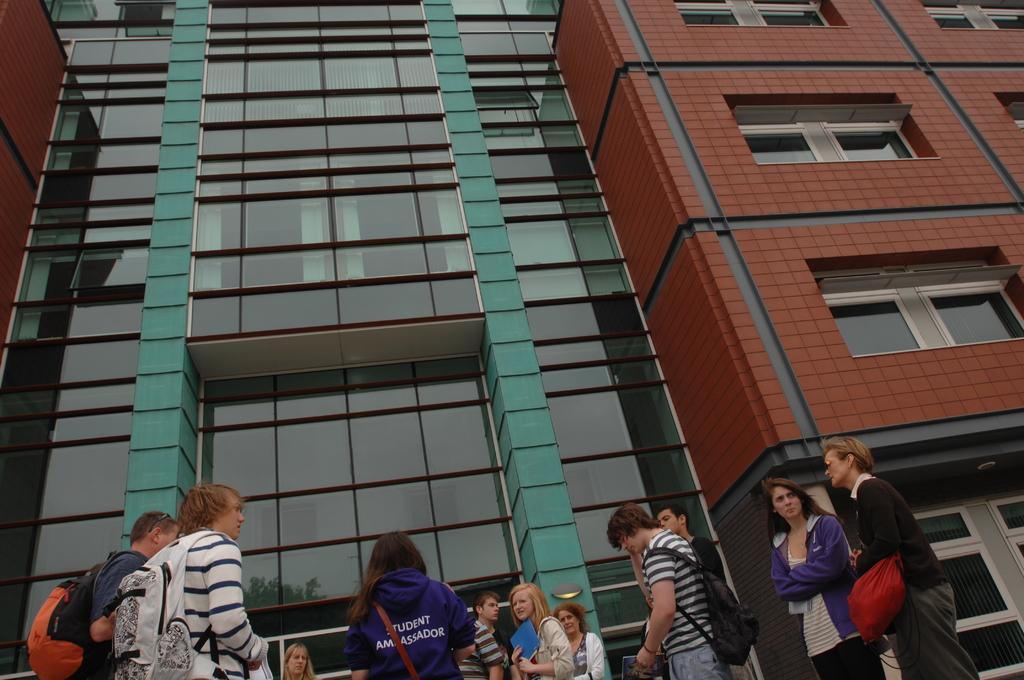How would you summarize this image in a sentence or two? In this picture there are group of people standing. At the back there is a building and there is a reflection of a tree on the mirror. 